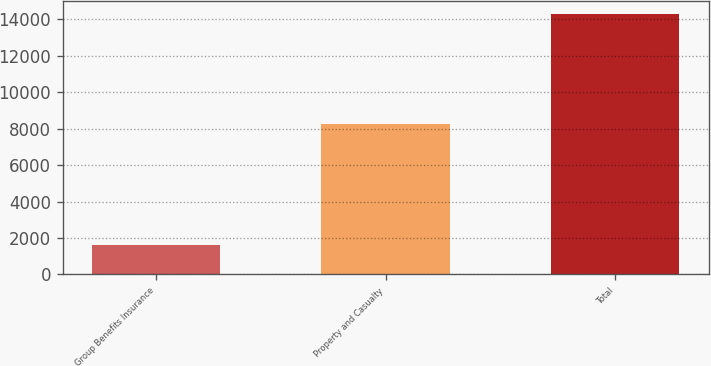<chart> <loc_0><loc_0><loc_500><loc_500><bar_chart><fcel>Group Benefits Insurance<fcel>Property and Casualty<fcel>Total<nl><fcel>1624<fcel>8261<fcel>14283<nl></chart> 